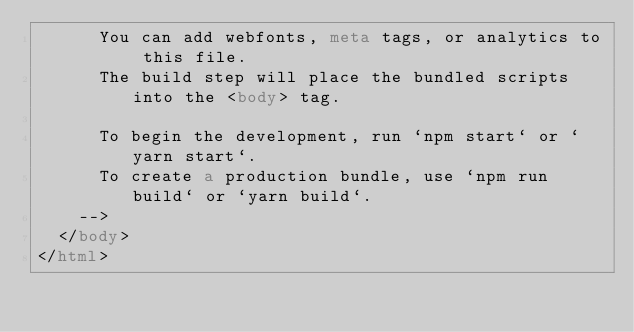<code> <loc_0><loc_0><loc_500><loc_500><_HTML_>      You can add webfonts, meta tags, or analytics to this file.
      The build step will place the bundled scripts into the <body> tag.

      To begin the development, run `npm start` or `yarn start`.
      To create a production bundle, use `npm run build` or `yarn build`.
    -->
  </body>
</html>
</code> 